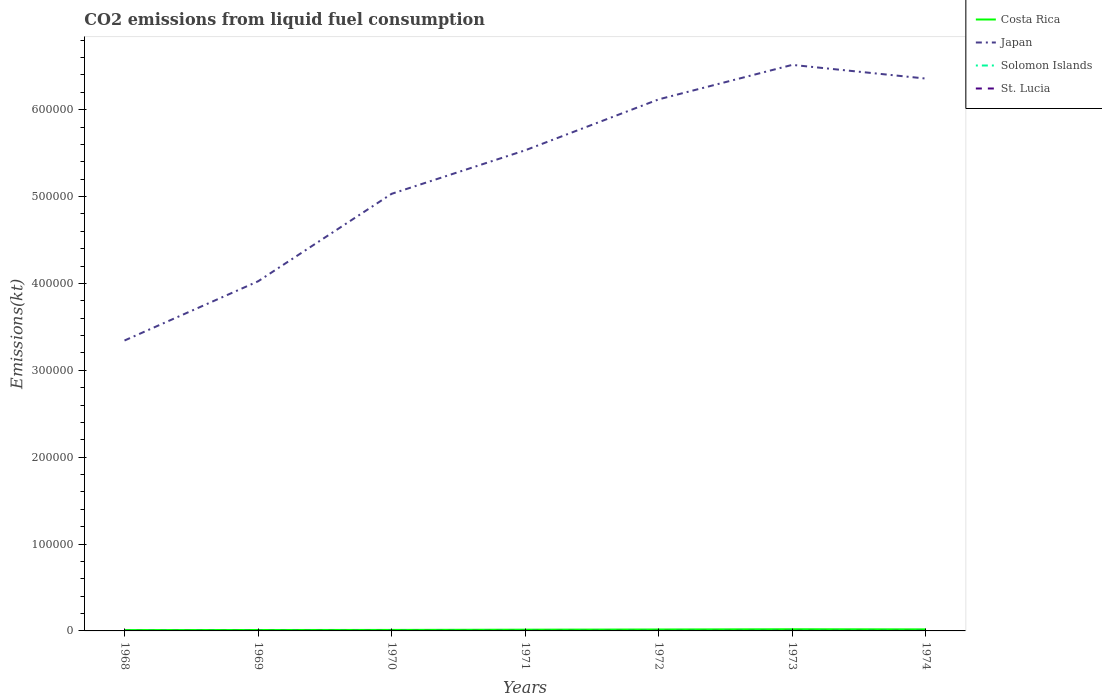How many different coloured lines are there?
Provide a succinct answer. 4. Does the line corresponding to Costa Rica intersect with the line corresponding to Solomon Islands?
Your answer should be compact. No. Across all years, what is the maximum amount of CO2 emitted in Costa Rica?
Offer a terse response. 971.75. In which year was the amount of CO2 emitted in St. Lucia maximum?
Ensure brevity in your answer.  1968. What is the total amount of CO2 emitted in Costa Rica in the graph?
Provide a succinct answer. -751.74. What is the difference between the highest and the second highest amount of CO2 emitted in St. Lucia?
Ensure brevity in your answer.  44. What is the difference between the highest and the lowest amount of CO2 emitted in St. Lucia?
Your answer should be compact. 4. How many lines are there?
Ensure brevity in your answer.  4. Are the values on the major ticks of Y-axis written in scientific E-notation?
Make the answer very short. No. Does the graph contain any zero values?
Give a very brief answer. No. Does the graph contain grids?
Ensure brevity in your answer.  No. Where does the legend appear in the graph?
Make the answer very short. Top right. How many legend labels are there?
Your answer should be compact. 4. How are the legend labels stacked?
Your answer should be very brief. Vertical. What is the title of the graph?
Make the answer very short. CO2 emissions from liquid fuel consumption. What is the label or title of the X-axis?
Offer a terse response. Years. What is the label or title of the Y-axis?
Provide a succinct answer. Emissions(kt). What is the Emissions(kt) of Costa Rica in 1968?
Your answer should be compact. 971.75. What is the Emissions(kt) in Japan in 1968?
Offer a terse response. 3.34e+05. What is the Emissions(kt) of Solomon Islands in 1968?
Your answer should be compact. 36.67. What is the Emissions(kt) in St. Lucia in 1968?
Ensure brevity in your answer.  36.67. What is the Emissions(kt) of Costa Rica in 1969?
Your answer should be very brief. 1067.1. What is the Emissions(kt) in Japan in 1969?
Your answer should be very brief. 4.02e+05. What is the Emissions(kt) in Solomon Islands in 1969?
Offer a terse response. 36.67. What is the Emissions(kt) in St. Lucia in 1969?
Offer a terse response. 62.34. What is the Emissions(kt) of Costa Rica in 1970?
Provide a short and direct response. 1158.77. What is the Emissions(kt) in Japan in 1970?
Provide a short and direct response. 5.03e+05. What is the Emissions(kt) in Solomon Islands in 1970?
Provide a succinct answer. 40.34. What is the Emissions(kt) of St. Lucia in 1970?
Offer a very short reply. 66.01. What is the Emissions(kt) of Costa Rica in 1971?
Provide a short and direct response. 1422.8. What is the Emissions(kt) in Japan in 1971?
Provide a short and direct response. 5.53e+05. What is the Emissions(kt) of Solomon Islands in 1971?
Keep it short and to the point. 47.67. What is the Emissions(kt) of St. Lucia in 1971?
Ensure brevity in your answer.  69.67. What is the Emissions(kt) in Costa Rica in 1972?
Your answer should be compact. 1631.82. What is the Emissions(kt) of Japan in 1972?
Offer a terse response. 6.12e+05. What is the Emissions(kt) in Solomon Islands in 1972?
Offer a very short reply. 55.01. What is the Emissions(kt) of St. Lucia in 1972?
Provide a short and direct response. 77.01. What is the Emissions(kt) in Costa Rica in 1973?
Make the answer very short. 1910.51. What is the Emissions(kt) of Japan in 1973?
Keep it short and to the point. 6.52e+05. What is the Emissions(kt) of Solomon Islands in 1973?
Provide a short and direct response. 66.01. What is the Emissions(kt) of St. Lucia in 1973?
Give a very brief answer. 80.67. What is the Emissions(kt) in Costa Rica in 1974?
Offer a terse response. 1760.16. What is the Emissions(kt) of Japan in 1974?
Your answer should be very brief. 6.36e+05. What is the Emissions(kt) of Solomon Islands in 1974?
Your answer should be very brief. 66.01. What is the Emissions(kt) of St. Lucia in 1974?
Make the answer very short. 73.34. Across all years, what is the maximum Emissions(kt) of Costa Rica?
Provide a short and direct response. 1910.51. Across all years, what is the maximum Emissions(kt) in Japan?
Offer a very short reply. 6.52e+05. Across all years, what is the maximum Emissions(kt) in Solomon Islands?
Provide a short and direct response. 66.01. Across all years, what is the maximum Emissions(kt) in St. Lucia?
Keep it short and to the point. 80.67. Across all years, what is the minimum Emissions(kt) of Costa Rica?
Make the answer very short. 971.75. Across all years, what is the minimum Emissions(kt) in Japan?
Your response must be concise. 3.34e+05. Across all years, what is the minimum Emissions(kt) in Solomon Islands?
Your answer should be very brief. 36.67. Across all years, what is the minimum Emissions(kt) of St. Lucia?
Your answer should be very brief. 36.67. What is the total Emissions(kt) in Costa Rica in the graph?
Keep it short and to the point. 9922.9. What is the total Emissions(kt) in Japan in the graph?
Provide a short and direct response. 3.69e+06. What is the total Emissions(kt) in Solomon Islands in the graph?
Offer a terse response. 348.37. What is the total Emissions(kt) of St. Lucia in the graph?
Your answer should be compact. 465.71. What is the difference between the Emissions(kt) in Costa Rica in 1968 and that in 1969?
Your answer should be compact. -95.34. What is the difference between the Emissions(kt) of Japan in 1968 and that in 1969?
Make the answer very short. -6.81e+04. What is the difference between the Emissions(kt) in Solomon Islands in 1968 and that in 1969?
Provide a succinct answer. 0. What is the difference between the Emissions(kt) of St. Lucia in 1968 and that in 1969?
Provide a short and direct response. -25.67. What is the difference between the Emissions(kt) of Costa Rica in 1968 and that in 1970?
Give a very brief answer. -187.02. What is the difference between the Emissions(kt) in Japan in 1968 and that in 1970?
Provide a short and direct response. -1.69e+05. What is the difference between the Emissions(kt) in Solomon Islands in 1968 and that in 1970?
Ensure brevity in your answer.  -3.67. What is the difference between the Emissions(kt) of St. Lucia in 1968 and that in 1970?
Offer a very short reply. -29.34. What is the difference between the Emissions(kt) in Costa Rica in 1968 and that in 1971?
Offer a terse response. -451.04. What is the difference between the Emissions(kt) of Japan in 1968 and that in 1971?
Give a very brief answer. -2.19e+05. What is the difference between the Emissions(kt) in Solomon Islands in 1968 and that in 1971?
Your response must be concise. -11. What is the difference between the Emissions(kt) in St. Lucia in 1968 and that in 1971?
Provide a short and direct response. -33. What is the difference between the Emissions(kt) in Costa Rica in 1968 and that in 1972?
Give a very brief answer. -660.06. What is the difference between the Emissions(kt) of Japan in 1968 and that in 1972?
Provide a succinct answer. -2.78e+05. What is the difference between the Emissions(kt) in Solomon Islands in 1968 and that in 1972?
Keep it short and to the point. -18.34. What is the difference between the Emissions(kt) of St. Lucia in 1968 and that in 1972?
Your answer should be compact. -40.34. What is the difference between the Emissions(kt) in Costa Rica in 1968 and that in 1973?
Offer a terse response. -938.75. What is the difference between the Emissions(kt) in Japan in 1968 and that in 1973?
Your answer should be compact. -3.17e+05. What is the difference between the Emissions(kt) in Solomon Islands in 1968 and that in 1973?
Provide a short and direct response. -29.34. What is the difference between the Emissions(kt) of St. Lucia in 1968 and that in 1973?
Provide a short and direct response. -44. What is the difference between the Emissions(kt) of Costa Rica in 1968 and that in 1974?
Your answer should be very brief. -788.4. What is the difference between the Emissions(kt) in Japan in 1968 and that in 1974?
Your response must be concise. -3.02e+05. What is the difference between the Emissions(kt) of Solomon Islands in 1968 and that in 1974?
Your answer should be very brief. -29.34. What is the difference between the Emissions(kt) in St. Lucia in 1968 and that in 1974?
Offer a terse response. -36.67. What is the difference between the Emissions(kt) in Costa Rica in 1969 and that in 1970?
Provide a succinct answer. -91.67. What is the difference between the Emissions(kt) of Japan in 1969 and that in 1970?
Keep it short and to the point. -1.01e+05. What is the difference between the Emissions(kt) of Solomon Islands in 1969 and that in 1970?
Offer a terse response. -3.67. What is the difference between the Emissions(kt) in St. Lucia in 1969 and that in 1970?
Your answer should be very brief. -3.67. What is the difference between the Emissions(kt) of Costa Rica in 1969 and that in 1971?
Give a very brief answer. -355.7. What is the difference between the Emissions(kt) in Japan in 1969 and that in 1971?
Offer a terse response. -1.51e+05. What is the difference between the Emissions(kt) in Solomon Islands in 1969 and that in 1971?
Ensure brevity in your answer.  -11. What is the difference between the Emissions(kt) of St. Lucia in 1969 and that in 1971?
Keep it short and to the point. -7.33. What is the difference between the Emissions(kt) of Costa Rica in 1969 and that in 1972?
Keep it short and to the point. -564.72. What is the difference between the Emissions(kt) of Japan in 1969 and that in 1972?
Your answer should be very brief. -2.09e+05. What is the difference between the Emissions(kt) in Solomon Islands in 1969 and that in 1972?
Provide a short and direct response. -18.34. What is the difference between the Emissions(kt) in St. Lucia in 1969 and that in 1972?
Keep it short and to the point. -14.67. What is the difference between the Emissions(kt) of Costa Rica in 1969 and that in 1973?
Keep it short and to the point. -843.41. What is the difference between the Emissions(kt) of Japan in 1969 and that in 1973?
Provide a short and direct response. -2.49e+05. What is the difference between the Emissions(kt) of Solomon Islands in 1969 and that in 1973?
Provide a short and direct response. -29.34. What is the difference between the Emissions(kt) in St. Lucia in 1969 and that in 1973?
Provide a succinct answer. -18.34. What is the difference between the Emissions(kt) of Costa Rica in 1969 and that in 1974?
Give a very brief answer. -693.06. What is the difference between the Emissions(kt) of Japan in 1969 and that in 1974?
Provide a succinct answer. -2.33e+05. What is the difference between the Emissions(kt) of Solomon Islands in 1969 and that in 1974?
Provide a succinct answer. -29.34. What is the difference between the Emissions(kt) of St. Lucia in 1969 and that in 1974?
Offer a very short reply. -11. What is the difference between the Emissions(kt) of Costa Rica in 1970 and that in 1971?
Ensure brevity in your answer.  -264.02. What is the difference between the Emissions(kt) in Japan in 1970 and that in 1971?
Make the answer very short. -5.01e+04. What is the difference between the Emissions(kt) in Solomon Islands in 1970 and that in 1971?
Offer a very short reply. -7.33. What is the difference between the Emissions(kt) in St. Lucia in 1970 and that in 1971?
Your answer should be compact. -3.67. What is the difference between the Emissions(kt) of Costa Rica in 1970 and that in 1972?
Your response must be concise. -473.04. What is the difference between the Emissions(kt) in Japan in 1970 and that in 1972?
Provide a short and direct response. -1.09e+05. What is the difference between the Emissions(kt) in Solomon Islands in 1970 and that in 1972?
Your answer should be very brief. -14.67. What is the difference between the Emissions(kt) of St. Lucia in 1970 and that in 1972?
Your response must be concise. -11. What is the difference between the Emissions(kt) of Costa Rica in 1970 and that in 1973?
Your answer should be very brief. -751.74. What is the difference between the Emissions(kt) in Japan in 1970 and that in 1973?
Ensure brevity in your answer.  -1.48e+05. What is the difference between the Emissions(kt) of Solomon Islands in 1970 and that in 1973?
Give a very brief answer. -25.67. What is the difference between the Emissions(kt) in St. Lucia in 1970 and that in 1973?
Keep it short and to the point. -14.67. What is the difference between the Emissions(kt) of Costa Rica in 1970 and that in 1974?
Offer a very short reply. -601.39. What is the difference between the Emissions(kt) in Japan in 1970 and that in 1974?
Provide a short and direct response. -1.33e+05. What is the difference between the Emissions(kt) in Solomon Islands in 1970 and that in 1974?
Give a very brief answer. -25.67. What is the difference between the Emissions(kt) in St. Lucia in 1970 and that in 1974?
Keep it short and to the point. -7.33. What is the difference between the Emissions(kt) in Costa Rica in 1971 and that in 1972?
Your answer should be very brief. -209.02. What is the difference between the Emissions(kt) of Japan in 1971 and that in 1972?
Keep it short and to the point. -5.87e+04. What is the difference between the Emissions(kt) of Solomon Islands in 1971 and that in 1972?
Provide a succinct answer. -7.33. What is the difference between the Emissions(kt) in St. Lucia in 1971 and that in 1972?
Keep it short and to the point. -7.33. What is the difference between the Emissions(kt) of Costa Rica in 1971 and that in 1973?
Offer a very short reply. -487.71. What is the difference between the Emissions(kt) in Japan in 1971 and that in 1973?
Your answer should be compact. -9.83e+04. What is the difference between the Emissions(kt) in Solomon Islands in 1971 and that in 1973?
Ensure brevity in your answer.  -18.34. What is the difference between the Emissions(kt) in St. Lucia in 1971 and that in 1973?
Your response must be concise. -11. What is the difference between the Emissions(kt) of Costa Rica in 1971 and that in 1974?
Give a very brief answer. -337.36. What is the difference between the Emissions(kt) of Japan in 1971 and that in 1974?
Give a very brief answer. -8.26e+04. What is the difference between the Emissions(kt) in Solomon Islands in 1971 and that in 1974?
Ensure brevity in your answer.  -18.34. What is the difference between the Emissions(kt) in St. Lucia in 1971 and that in 1974?
Ensure brevity in your answer.  -3.67. What is the difference between the Emissions(kt) of Costa Rica in 1972 and that in 1973?
Offer a terse response. -278.69. What is the difference between the Emissions(kt) in Japan in 1972 and that in 1973?
Your response must be concise. -3.97e+04. What is the difference between the Emissions(kt) of Solomon Islands in 1972 and that in 1973?
Ensure brevity in your answer.  -11. What is the difference between the Emissions(kt) of St. Lucia in 1972 and that in 1973?
Make the answer very short. -3.67. What is the difference between the Emissions(kt) of Costa Rica in 1972 and that in 1974?
Provide a succinct answer. -128.34. What is the difference between the Emissions(kt) in Japan in 1972 and that in 1974?
Your answer should be compact. -2.39e+04. What is the difference between the Emissions(kt) of Solomon Islands in 1972 and that in 1974?
Give a very brief answer. -11. What is the difference between the Emissions(kt) of St. Lucia in 1972 and that in 1974?
Give a very brief answer. 3.67. What is the difference between the Emissions(kt) of Costa Rica in 1973 and that in 1974?
Make the answer very short. 150.35. What is the difference between the Emissions(kt) of Japan in 1973 and that in 1974?
Offer a very short reply. 1.58e+04. What is the difference between the Emissions(kt) of Solomon Islands in 1973 and that in 1974?
Your answer should be compact. 0. What is the difference between the Emissions(kt) in St. Lucia in 1973 and that in 1974?
Provide a succinct answer. 7.33. What is the difference between the Emissions(kt) in Costa Rica in 1968 and the Emissions(kt) in Japan in 1969?
Provide a succinct answer. -4.01e+05. What is the difference between the Emissions(kt) in Costa Rica in 1968 and the Emissions(kt) in Solomon Islands in 1969?
Your answer should be compact. 935.09. What is the difference between the Emissions(kt) in Costa Rica in 1968 and the Emissions(kt) in St. Lucia in 1969?
Your answer should be compact. 909.42. What is the difference between the Emissions(kt) in Japan in 1968 and the Emissions(kt) in Solomon Islands in 1969?
Your response must be concise. 3.34e+05. What is the difference between the Emissions(kt) in Japan in 1968 and the Emissions(kt) in St. Lucia in 1969?
Provide a succinct answer. 3.34e+05. What is the difference between the Emissions(kt) in Solomon Islands in 1968 and the Emissions(kt) in St. Lucia in 1969?
Ensure brevity in your answer.  -25.67. What is the difference between the Emissions(kt) of Costa Rica in 1968 and the Emissions(kt) of Japan in 1970?
Provide a succinct answer. -5.02e+05. What is the difference between the Emissions(kt) in Costa Rica in 1968 and the Emissions(kt) in Solomon Islands in 1970?
Your response must be concise. 931.42. What is the difference between the Emissions(kt) in Costa Rica in 1968 and the Emissions(kt) in St. Lucia in 1970?
Make the answer very short. 905.75. What is the difference between the Emissions(kt) in Japan in 1968 and the Emissions(kt) in Solomon Islands in 1970?
Your response must be concise. 3.34e+05. What is the difference between the Emissions(kt) in Japan in 1968 and the Emissions(kt) in St. Lucia in 1970?
Your answer should be very brief. 3.34e+05. What is the difference between the Emissions(kt) in Solomon Islands in 1968 and the Emissions(kt) in St. Lucia in 1970?
Your answer should be compact. -29.34. What is the difference between the Emissions(kt) of Costa Rica in 1968 and the Emissions(kt) of Japan in 1971?
Make the answer very short. -5.52e+05. What is the difference between the Emissions(kt) in Costa Rica in 1968 and the Emissions(kt) in Solomon Islands in 1971?
Provide a short and direct response. 924.08. What is the difference between the Emissions(kt) in Costa Rica in 1968 and the Emissions(kt) in St. Lucia in 1971?
Your answer should be compact. 902.08. What is the difference between the Emissions(kt) in Japan in 1968 and the Emissions(kt) in Solomon Islands in 1971?
Keep it short and to the point. 3.34e+05. What is the difference between the Emissions(kt) of Japan in 1968 and the Emissions(kt) of St. Lucia in 1971?
Your answer should be very brief. 3.34e+05. What is the difference between the Emissions(kt) of Solomon Islands in 1968 and the Emissions(kt) of St. Lucia in 1971?
Ensure brevity in your answer.  -33. What is the difference between the Emissions(kt) of Costa Rica in 1968 and the Emissions(kt) of Japan in 1972?
Provide a succinct answer. -6.11e+05. What is the difference between the Emissions(kt) in Costa Rica in 1968 and the Emissions(kt) in Solomon Islands in 1972?
Make the answer very short. 916.75. What is the difference between the Emissions(kt) in Costa Rica in 1968 and the Emissions(kt) in St. Lucia in 1972?
Provide a short and direct response. 894.75. What is the difference between the Emissions(kt) in Japan in 1968 and the Emissions(kt) in Solomon Islands in 1972?
Ensure brevity in your answer.  3.34e+05. What is the difference between the Emissions(kt) in Japan in 1968 and the Emissions(kt) in St. Lucia in 1972?
Your answer should be compact. 3.34e+05. What is the difference between the Emissions(kt) of Solomon Islands in 1968 and the Emissions(kt) of St. Lucia in 1972?
Give a very brief answer. -40.34. What is the difference between the Emissions(kt) in Costa Rica in 1968 and the Emissions(kt) in Japan in 1973?
Ensure brevity in your answer.  -6.51e+05. What is the difference between the Emissions(kt) of Costa Rica in 1968 and the Emissions(kt) of Solomon Islands in 1973?
Offer a very short reply. 905.75. What is the difference between the Emissions(kt) in Costa Rica in 1968 and the Emissions(kt) in St. Lucia in 1973?
Make the answer very short. 891.08. What is the difference between the Emissions(kt) of Japan in 1968 and the Emissions(kt) of Solomon Islands in 1973?
Make the answer very short. 3.34e+05. What is the difference between the Emissions(kt) of Japan in 1968 and the Emissions(kt) of St. Lucia in 1973?
Ensure brevity in your answer.  3.34e+05. What is the difference between the Emissions(kt) of Solomon Islands in 1968 and the Emissions(kt) of St. Lucia in 1973?
Offer a terse response. -44. What is the difference between the Emissions(kt) in Costa Rica in 1968 and the Emissions(kt) in Japan in 1974?
Your answer should be compact. -6.35e+05. What is the difference between the Emissions(kt) of Costa Rica in 1968 and the Emissions(kt) of Solomon Islands in 1974?
Offer a very short reply. 905.75. What is the difference between the Emissions(kt) of Costa Rica in 1968 and the Emissions(kt) of St. Lucia in 1974?
Keep it short and to the point. 898.41. What is the difference between the Emissions(kt) in Japan in 1968 and the Emissions(kt) in Solomon Islands in 1974?
Provide a succinct answer. 3.34e+05. What is the difference between the Emissions(kt) in Japan in 1968 and the Emissions(kt) in St. Lucia in 1974?
Ensure brevity in your answer.  3.34e+05. What is the difference between the Emissions(kt) in Solomon Islands in 1968 and the Emissions(kt) in St. Lucia in 1974?
Provide a succinct answer. -36.67. What is the difference between the Emissions(kt) in Costa Rica in 1969 and the Emissions(kt) in Japan in 1970?
Keep it short and to the point. -5.02e+05. What is the difference between the Emissions(kt) in Costa Rica in 1969 and the Emissions(kt) in Solomon Islands in 1970?
Offer a terse response. 1026.76. What is the difference between the Emissions(kt) in Costa Rica in 1969 and the Emissions(kt) in St. Lucia in 1970?
Make the answer very short. 1001.09. What is the difference between the Emissions(kt) in Japan in 1969 and the Emissions(kt) in Solomon Islands in 1970?
Keep it short and to the point. 4.02e+05. What is the difference between the Emissions(kt) of Japan in 1969 and the Emissions(kt) of St. Lucia in 1970?
Your response must be concise. 4.02e+05. What is the difference between the Emissions(kt) in Solomon Islands in 1969 and the Emissions(kt) in St. Lucia in 1970?
Offer a terse response. -29.34. What is the difference between the Emissions(kt) in Costa Rica in 1969 and the Emissions(kt) in Japan in 1971?
Provide a short and direct response. -5.52e+05. What is the difference between the Emissions(kt) in Costa Rica in 1969 and the Emissions(kt) in Solomon Islands in 1971?
Keep it short and to the point. 1019.43. What is the difference between the Emissions(kt) in Costa Rica in 1969 and the Emissions(kt) in St. Lucia in 1971?
Make the answer very short. 997.42. What is the difference between the Emissions(kt) in Japan in 1969 and the Emissions(kt) in Solomon Islands in 1971?
Make the answer very short. 4.02e+05. What is the difference between the Emissions(kt) of Japan in 1969 and the Emissions(kt) of St. Lucia in 1971?
Provide a succinct answer. 4.02e+05. What is the difference between the Emissions(kt) of Solomon Islands in 1969 and the Emissions(kt) of St. Lucia in 1971?
Your answer should be very brief. -33. What is the difference between the Emissions(kt) of Costa Rica in 1969 and the Emissions(kt) of Japan in 1972?
Keep it short and to the point. -6.11e+05. What is the difference between the Emissions(kt) in Costa Rica in 1969 and the Emissions(kt) in Solomon Islands in 1972?
Offer a very short reply. 1012.09. What is the difference between the Emissions(kt) of Costa Rica in 1969 and the Emissions(kt) of St. Lucia in 1972?
Make the answer very short. 990.09. What is the difference between the Emissions(kt) in Japan in 1969 and the Emissions(kt) in Solomon Islands in 1972?
Offer a very short reply. 4.02e+05. What is the difference between the Emissions(kt) of Japan in 1969 and the Emissions(kt) of St. Lucia in 1972?
Your answer should be compact. 4.02e+05. What is the difference between the Emissions(kt) of Solomon Islands in 1969 and the Emissions(kt) of St. Lucia in 1972?
Ensure brevity in your answer.  -40.34. What is the difference between the Emissions(kt) in Costa Rica in 1969 and the Emissions(kt) in Japan in 1973?
Provide a succinct answer. -6.50e+05. What is the difference between the Emissions(kt) in Costa Rica in 1969 and the Emissions(kt) in Solomon Islands in 1973?
Keep it short and to the point. 1001.09. What is the difference between the Emissions(kt) in Costa Rica in 1969 and the Emissions(kt) in St. Lucia in 1973?
Offer a very short reply. 986.42. What is the difference between the Emissions(kt) of Japan in 1969 and the Emissions(kt) of Solomon Islands in 1973?
Provide a short and direct response. 4.02e+05. What is the difference between the Emissions(kt) in Japan in 1969 and the Emissions(kt) in St. Lucia in 1973?
Your response must be concise. 4.02e+05. What is the difference between the Emissions(kt) in Solomon Islands in 1969 and the Emissions(kt) in St. Lucia in 1973?
Provide a short and direct response. -44. What is the difference between the Emissions(kt) of Costa Rica in 1969 and the Emissions(kt) of Japan in 1974?
Your answer should be compact. -6.35e+05. What is the difference between the Emissions(kt) of Costa Rica in 1969 and the Emissions(kt) of Solomon Islands in 1974?
Your answer should be compact. 1001.09. What is the difference between the Emissions(kt) in Costa Rica in 1969 and the Emissions(kt) in St. Lucia in 1974?
Provide a succinct answer. 993.76. What is the difference between the Emissions(kt) in Japan in 1969 and the Emissions(kt) in Solomon Islands in 1974?
Offer a very short reply. 4.02e+05. What is the difference between the Emissions(kt) in Japan in 1969 and the Emissions(kt) in St. Lucia in 1974?
Your answer should be very brief. 4.02e+05. What is the difference between the Emissions(kt) in Solomon Islands in 1969 and the Emissions(kt) in St. Lucia in 1974?
Provide a succinct answer. -36.67. What is the difference between the Emissions(kt) of Costa Rica in 1970 and the Emissions(kt) of Japan in 1971?
Keep it short and to the point. -5.52e+05. What is the difference between the Emissions(kt) in Costa Rica in 1970 and the Emissions(kt) in Solomon Islands in 1971?
Keep it short and to the point. 1111.1. What is the difference between the Emissions(kt) in Costa Rica in 1970 and the Emissions(kt) in St. Lucia in 1971?
Provide a succinct answer. 1089.1. What is the difference between the Emissions(kt) in Japan in 1970 and the Emissions(kt) in Solomon Islands in 1971?
Give a very brief answer. 5.03e+05. What is the difference between the Emissions(kt) of Japan in 1970 and the Emissions(kt) of St. Lucia in 1971?
Ensure brevity in your answer.  5.03e+05. What is the difference between the Emissions(kt) in Solomon Islands in 1970 and the Emissions(kt) in St. Lucia in 1971?
Offer a very short reply. -29.34. What is the difference between the Emissions(kt) in Costa Rica in 1970 and the Emissions(kt) in Japan in 1972?
Offer a very short reply. -6.11e+05. What is the difference between the Emissions(kt) in Costa Rica in 1970 and the Emissions(kt) in Solomon Islands in 1972?
Your response must be concise. 1103.77. What is the difference between the Emissions(kt) in Costa Rica in 1970 and the Emissions(kt) in St. Lucia in 1972?
Offer a terse response. 1081.77. What is the difference between the Emissions(kt) in Japan in 1970 and the Emissions(kt) in Solomon Islands in 1972?
Offer a terse response. 5.03e+05. What is the difference between the Emissions(kt) in Japan in 1970 and the Emissions(kt) in St. Lucia in 1972?
Provide a succinct answer. 5.03e+05. What is the difference between the Emissions(kt) in Solomon Islands in 1970 and the Emissions(kt) in St. Lucia in 1972?
Your response must be concise. -36.67. What is the difference between the Emissions(kt) in Costa Rica in 1970 and the Emissions(kt) in Japan in 1973?
Give a very brief answer. -6.50e+05. What is the difference between the Emissions(kt) in Costa Rica in 1970 and the Emissions(kt) in Solomon Islands in 1973?
Give a very brief answer. 1092.77. What is the difference between the Emissions(kt) in Costa Rica in 1970 and the Emissions(kt) in St. Lucia in 1973?
Your response must be concise. 1078.1. What is the difference between the Emissions(kt) of Japan in 1970 and the Emissions(kt) of Solomon Islands in 1973?
Give a very brief answer. 5.03e+05. What is the difference between the Emissions(kt) in Japan in 1970 and the Emissions(kt) in St. Lucia in 1973?
Provide a short and direct response. 5.03e+05. What is the difference between the Emissions(kt) in Solomon Islands in 1970 and the Emissions(kt) in St. Lucia in 1973?
Keep it short and to the point. -40.34. What is the difference between the Emissions(kt) in Costa Rica in 1970 and the Emissions(kt) in Japan in 1974?
Offer a terse response. -6.35e+05. What is the difference between the Emissions(kt) of Costa Rica in 1970 and the Emissions(kt) of Solomon Islands in 1974?
Provide a short and direct response. 1092.77. What is the difference between the Emissions(kt) of Costa Rica in 1970 and the Emissions(kt) of St. Lucia in 1974?
Your answer should be very brief. 1085.43. What is the difference between the Emissions(kt) in Japan in 1970 and the Emissions(kt) in Solomon Islands in 1974?
Keep it short and to the point. 5.03e+05. What is the difference between the Emissions(kt) of Japan in 1970 and the Emissions(kt) of St. Lucia in 1974?
Offer a very short reply. 5.03e+05. What is the difference between the Emissions(kt) of Solomon Islands in 1970 and the Emissions(kt) of St. Lucia in 1974?
Give a very brief answer. -33. What is the difference between the Emissions(kt) of Costa Rica in 1971 and the Emissions(kt) of Japan in 1972?
Offer a terse response. -6.10e+05. What is the difference between the Emissions(kt) in Costa Rica in 1971 and the Emissions(kt) in Solomon Islands in 1972?
Your response must be concise. 1367.79. What is the difference between the Emissions(kt) in Costa Rica in 1971 and the Emissions(kt) in St. Lucia in 1972?
Your response must be concise. 1345.79. What is the difference between the Emissions(kt) of Japan in 1971 and the Emissions(kt) of Solomon Islands in 1972?
Your response must be concise. 5.53e+05. What is the difference between the Emissions(kt) in Japan in 1971 and the Emissions(kt) in St. Lucia in 1972?
Your response must be concise. 5.53e+05. What is the difference between the Emissions(kt) of Solomon Islands in 1971 and the Emissions(kt) of St. Lucia in 1972?
Provide a succinct answer. -29.34. What is the difference between the Emissions(kt) in Costa Rica in 1971 and the Emissions(kt) in Japan in 1973?
Provide a succinct answer. -6.50e+05. What is the difference between the Emissions(kt) in Costa Rica in 1971 and the Emissions(kt) in Solomon Islands in 1973?
Offer a terse response. 1356.79. What is the difference between the Emissions(kt) in Costa Rica in 1971 and the Emissions(kt) in St. Lucia in 1973?
Your answer should be very brief. 1342.12. What is the difference between the Emissions(kt) of Japan in 1971 and the Emissions(kt) of Solomon Islands in 1973?
Provide a succinct answer. 5.53e+05. What is the difference between the Emissions(kt) in Japan in 1971 and the Emissions(kt) in St. Lucia in 1973?
Offer a very short reply. 5.53e+05. What is the difference between the Emissions(kt) of Solomon Islands in 1971 and the Emissions(kt) of St. Lucia in 1973?
Keep it short and to the point. -33. What is the difference between the Emissions(kt) of Costa Rica in 1971 and the Emissions(kt) of Japan in 1974?
Offer a terse response. -6.34e+05. What is the difference between the Emissions(kt) in Costa Rica in 1971 and the Emissions(kt) in Solomon Islands in 1974?
Offer a very short reply. 1356.79. What is the difference between the Emissions(kt) of Costa Rica in 1971 and the Emissions(kt) of St. Lucia in 1974?
Give a very brief answer. 1349.46. What is the difference between the Emissions(kt) of Japan in 1971 and the Emissions(kt) of Solomon Islands in 1974?
Offer a terse response. 5.53e+05. What is the difference between the Emissions(kt) of Japan in 1971 and the Emissions(kt) of St. Lucia in 1974?
Your answer should be very brief. 5.53e+05. What is the difference between the Emissions(kt) of Solomon Islands in 1971 and the Emissions(kt) of St. Lucia in 1974?
Make the answer very short. -25.67. What is the difference between the Emissions(kt) in Costa Rica in 1972 and the Emissions(kt) in Japan in 1973?
Give a very brief answer. -6.50e+05. What is the difference between the Emissions(kt) in Costa Rica in 1972 and the Emissions(kt) in Solomon Islands in 1973?
Ensure brevity in your answer.  1565.81. What is the difference between the Emissions(kt) in Costa Rica in 1972 and the Emissions(kt) in St. Lucia in 1973?
Make the answer very short. 1551.14. What is the difference between the Emissions(kt) in Japan in 1972 and the Emissions(kt) in Solomon Islands in 1973?
Offer a terse response. 6.12e+05. What is the difference between the Emissions(kt) of Japan in 1972 and the Emissions(kt) of St. Lucia in 1973?
Provide a succinct answer. 6.12e+05. What is the difference between the Emissions(kt) of Solomon Islands in 1972 and the Emissions(kt) of St. Lucia in 1973?
Provide a short and direct response. -25.67. What is the difference between the Emissions(kt) of Costa Rica in 1972 and the Emissions(kt) of Japan in 1974?
Your answer should be very brief. -6.34e+05. What is the difference between the Emissions(kt) in Costa Rica in 1972 and the Emissions(kt) in Solomon Islands in 1974?
Keep it short and to the point. 1565.81. What is the difference between the Emissions(kt) in Costa Rica in 1972 and the Emissions(kt) in St. Lucia in 1974?
Your response must be concise. 1558.47. What is the difference between the Emissions(kt) in Japan in 1972 and the Emissions(kt) in Solomon Islands in 1974?
Make the answer very short. 6.12e+05. What is the difference between the Emissions(kt) in Japan in 1972 and the Emissions(kt) in St. Lucia in 1974?
Ensure brevity in your answer.  6.12e+05. What is the difference between the Emissions(kt) of Solomon Islands in 1972 and the Emissions(kt) of St. Lucia in 1974?
Provide a short and direct response. -18.34. What is the difference between the Emissions(kt) in Costa Rica in 1973 and the Emissions(kt) in Japan in 1974?
Your response must be concise. -6.34e+05. What is the difference between the Emissions(kt) of Costa Rica in 1973 and the Emissions(kt) of Solomon Islands in 1974?
Provide a short and direct response. 1844.5. What is the difference between the Emissions(kt) of Costa Rica in 1973 and the Emissions(kt) of St. Lucia in 1974?
Offer a very short reply. 1837.17. What is the difference between the Emissions(kt) of Japan in 1973 and the Emissions(kt) of Solomon Islands in 1974?
Offer a very short reply. 6.51e+05. What is the difference between the Emissions(kt) in Japan in 1973 and the Emissions(kt) in St. Lucia in 1974?
Offer a terse response. 6.51e+05. What is the difference between the Emissions(kt) of Solomon Islands in 1973 and the Emissions(kt) of St. Lucia in 1974?
Your answer should be compact. -7.33. What is the average Emissions(kt) in Costa Rica per year?
Your response must be concise. 1417.56. What is the average Emissions(kt) of Japan per year?
Offer a very short reply. 5.27e+05. What is the average Emissions(kt) in Solomon Islands per year?
Your answer should be very brief. 49.77. What is the average Emissions(kt) of St. Lucia per year?
Your response must be concise. 66.53. In the year 1968, what is the difference between the Emissions(kt) in Costa Rica and Emissions(kt) in Japan?
Offer a very short reply. -3.33e+05. In the year 1968, what is the difference between the Emissions(kt) in Costa Rica and Emissions(kt) in Solomon Islands?
Make the answer very short. 935.09. In the year 1968, what is the difference between the Emissions(kt) of Costa Rica and Emissions(kt) of St. Lucia?
Offer a terse response. 935.09. In the year 1968, what is the difference between the Emissions(kt) of Japan and Emissions(kt) of Solomon Islands?
Offer a terse response. 3.34e+05. In the year 1968, what is the difference between the Emissions(kt) in Japan and Emissions(kt) in St. Lucia?
Give a very brief answer. 3.34e+05. In the year 1968, what is the difference between the Emissions(kt) in Solomon Islands and Emissions(kt) in St. Lucia?
Ensure brevity in your answer.  0. In the year 1969, what is the difference between the Emissions(kt) of Costa Rica and Emissions(kt) of Japan?
Offer a very short reply. -4.01e+05. In the year 1969, what is the difference between the Emissions(kt) in Costa Rica and Emissions(kt) in Solomon Islands?
Ensure brevity in your answer.  1030.43. In the year 1969, what is the difference between the Emissions(kt) of Costa Rica and Emissions(kt) of St. Lucia?
Offer a terse response. 1004.76. In the year 1969, what is the difference between the Emissions(kt) of Japan and Emissions(kt) of Solomon Islands?
Offer a terse response. 4.02e+05. In the year 1969, what is the difference between the Emissions(kt) of Japan and Emissions(kt) of St. Lucia?
Give a very brief answer. 4.02e+05. In the year 1969, what is the difference between the Emissions(kt) in Solomon Islands and Emissions(kt) in St. Lucia?
Ensure brevity in your answer.  -25.67. In the year 1970, what is the difference between the Emissions(kt) of Costa Rica and Emissions(kt) of Japan?
Make the answer very short. -5.02e+05. In the year 1970, what is the difference between the Emissions(kt) in Costa Rica and Emissions(kt) in Solomon Islands?
Provide a succinct answer. 1118.43. In the year 1970, what is the difference between the Emissions(kt) of Costa Rica and Emissions(kt) of St. Lucia?
Offer a very short reply. 1092.77. In the year 1970, what is the difference between the Emissions(kt) of Japan and Emissions(kt) of Solomon Islands?
Give a very brief answer. 5.03e+05. In the year 1970, what is the difference between the Emissions(kt) in Japan and Emissions(kt) in St. Lucia?
Your answer should be very brief. 5.03e+05. In the year 1970, what is the difference between the Emissions(kt) in Solomon Islands and Emissions(kt) in St. Lucia?
Give a very brief answer. -25.67. In the year 1971, what is the difference between the Emissions(kt) in Costa Rica and Emissions(kt) in Japan?
Your answer should be compact. -5.52e+05. In the year 1971, what is the difference between the Emissions(kt) of Costa Rica and Emissions(kt) of Solomon Islands?
Keep it short and to the point. 1375.12. In the year 1971, what is the difference between the Emissions(kt) in Costa Rica and Emissions(kt) in St. Lucia?
Make the answer very short. 1353.12. In the year 1971, what is the difference between the Emissions(kt) of Japan and Emissions(kt) of Solomon Islands?
Ensure brevity in your answer.  5.53e+05. In the year 1971, what is the difference between the Emissions(kt) in Japan and Emissions(kt) in St. Lucia?
Your answer should be compact. 5.53e+05. In the year 1971, what is the difference between the Emissions(kt) in Solomon Islands and Emissions(kt) in St. Lucia?
Your response must be concise. -22. In the year 1972, what is the difference between the Emissions(kt) of Costa Rica and Emissions(kt) of Japan?
Give a very brief answer. -6.10e+05. In the year 1972, what is the difference between the Emissions(kt) of Costa Rica and Emissions(kt) of Solomon Islands?
Your response must be concise. 1576.81. In the year 1972, what is the difference between the Emissions(kt) in Costa Rica and Emissions(kt) in St. Lucia?
Provide a succinct answer. 1554.81. In the year 1972, what is the difference between the Emissions(kt) in Japan and Emissions(kt) in Solomon Islands?
Ensure brevity in your answer.  6.12e+05. In the year 1972, what is the difference between the Emissions(kt) in Japan and Emissions(kt) in St. Lucia?
Make the answer very short. 6.12e+05. In the year 1972, what is the difference between the Emissions(kt) of Solomon Islands and Emissions(kt) of St. Lucia?
Your answer should be compact. -22. In the year 1973, what is the difference between the Emissions(kt) of Costa Rica and Emissions(kt) of Japan?
Provide a succinct answer. -6.50e+05. In the year 1973, what is the difference between the Emissions(kt) of Costa Rica and Emissions(kt) of Solomon Islands?
Your response must be concise. 1844.5. In the year 1973, what is the difference between the Emissions(kt) in Costa Rica and Emissions(kt) in St. Lucia?
Provide a succinct answer. 1829.83. In the year 1973, what is the difference between the Emissions(kt) of Japan and Emissions(kt) of Solomon Islands?
Keep it short and to the point. 6.51e+05. In the year 1973, what is the difference between the Emissions(kt) of Japan and Emissions(kt) of St. Lucia?
Keep it short and to the point. 6.51e+05. In the year 1973, what is the difference between the Emissions(kt) of Solomon Islands and Emissions(kt) of St. Lucia?
Your response must be concise. -14.67. In the year 1974, what is the difference between the Emissions(kt) of Costa Rica and Emissions(kt) of Japan?
Your answer should be very brief. -6.34e+05. In the year 1974, what is the difference between the Emissions(kt) in Costa Rica and Emissions(kt) in Solomon Islands?
Your answer should be very brief. 1694.15. In the year 1974, what is the difference between the Emissions(kt) in Costa Rica and Emissions(kt) in St. Lucia?
Your answer should be compact. 1686.82. In the year 1974, what is the difference between the Emissions(kt) of Japan and Emissions(kt) of Solomon Islands?
Your response must be concise. 6.36e+05. In the year 1974, what is the difference between the Emissions(kt) in Japan and Emissions(kt) in St. Lucia?
Keep it short and to the point. 6.36e+05. In the year 1974, what is the difference between the Emissions(kt) in Solomon Islands and Emissions(kt) in St. Lucia?
Give a very brief answer. -7.33. What is the ratio of the Emissions(kt) in Costa Rica in 1968 to that in 1969?
Your answer should be very brief. 0.91. What is the ratio of the Emissions(kt) in Japan in 1968 to that in 1969?
Offer a terse response. 0.83. What is the ratio of the Emissions(kt) of Solomon Islands in 1968 to that in 1969?
Make the answer very short. 1. What is the ratio of the Emissions(kt) in St. Lucia in 1968 to that in 1969?
Offer a very short reply. 0.59. What is the ratio of the Emissions(kt) of Costa Rica in 1968 to that in 1970?
Your response must be concise. 0.84. What is the ratio of the Emissions(kt) of Japan in 1968 to that in 1970?
Give a very brief answer. 0.66. What is the ratio of the Emissions(kt) in Solomon Islands in 1968 to that in 1970?
Your answer should be compact. 0.91. What is the ratio of the Emissions(kt) of St. Lucia in 1968 to that in 1970?
Give a very brief answer. 0.56. What is the ratio of the Emissions(kt) of Costa Rica in 1968 to that in 1971?
Offer a terse response. 0.68. What is the ratio of the Emissions(kt) of Japan in 1968 to that in 1971?
Give a very brief answer. 0.6. What is the ratio of the Emissions(kt) in Solomon Islands in 1968 to that in 1971?
Provide a succinct answer. 0.77. What is the ratio of the Emissions(kt) of St. Lucia in 1968 to that in 1971?
Offer a very short reply. 0.53. What is the ratio of the Emissions(kt) in Costa Rica in 1968 to that in 1972?
Provide a short and direct response. 0.6. What is the ratio of the Emissions(kt) of Japan in 1968 to that in 1972?
Offer a very short reply. 0.55. What is the ratio of the Emissions(kt) of St. Lucia in 1968 to that in 1972?
Your response must be concise. 0.48. What is the ratio of the Emissions(kt) in Costa Rica in 1968 to that in 1973?
Give a very brief answer. 0.51. What is the ratio of the Emissions(kt) of Japan in 1968 to that in 1973?
Your response must be concise. 0.51. What is the ratio of the Emissions(kt) of Solomon Islands in 1968 to that in 1973?
Your response must be concise. 0.56. What is the ratio of the Emissions(kt) in St. Lucia in 1968 to that in 1973?
Provide a succinct answer. 0.45. What is the ratio of the Emissions(kt) in Costa Rica in 1968 to that in 1974?
Keep it short and to the point. 0.55. What is the ratio of the Emissions(kt) in Japan in 1968 to that in 1974?
Make the answer very short. 0.53. What is the ratio of the Emissions(kt) of Solomon Islands in 1968 to that in 1974?
Your response must be concise. 0.56. What is the ratio of the Emissions(kt) in St. Lucia in 1968 to that in 1974?
Your response must be concise. 0.5. What is the ratio of the Emissions(kt) in Costa Rica in 1969 to that in 1970?
Provide a short and direct response. 0.92. What is the ratio of the Emissions(kt) of Japan in 1969 to that in 1970?
Make the answer very short. 0.8. What is the ratio of the Emissions(kt) of St. Lucia in 1969 to that in 1970?
Ensure brevity in your answer.  0.94. What is the ratio of the Emissions(kt) in Japan in 1969 to that in 1971?
Give a very brief answer. 0.73. What is the ratio of the Emissions(kt) in Solomon Islands in 1969 to that in 1971?
Make the answer very short. 0.77. What is the ratio of the Emissions(kt) of St. Lucia in 1969 to that in 1971?
Your answer should be very brief. 0.89. What is the ratio of the Emissions(kt) in Costa Rica in 1969 to that in 1972?
Your answer should be compact. 0.65. What is the ratio of the Emissions(kt) in Japan in 1969 to that in 1972?
Give a very brief answer. 0.66. What is the ratio of the Emissions(kt) of Solomon Islands in 1969 to that in 1972?
Keep it short and to the point. 0.67. What is the ratio of the Emissions(kt) of St. Lucia in 1969 to that in 1972?
Your answer should be compact. 0.81. What is the ratio of the Emissions(kt) in Costa Rica in 1969 to that in 1973?
Give a very brief answer. 0.56. What is the ratio of the Emissions(kt) of Japan in 1969 to that in 1973?
Make the answer very short. 0.62. What is the ratio of the Emissions(kt) of Solomon Islands in 1969 to that in 1973?
Your answer should be compact. 0.56. What is the ratio of the Emissions(kt) in St. Lucia in 1969 to that in 1973?
Ensure brevity in your answer.  0.77. What is the ratio of the Emissions(kt) in Costa Rica in 1969 to that in 1974?
Your answer should be compact. 0.61. What is the ratio of the Emissions(kt) in Japan in 1969 to that in 1974?
Give a very brief answer. 0.63. What is the ratio of the Emissions(kt) of Solomon Islands in 1969 to that in 1974?
Your answer should be very brief. 0.56. What is the ratio of the Emissions(kt) of St. Lucia in 1969 to that in 1974?
Offer a very short reply. 0.85. What is the ratio of the Emissions(kt) of Costa Rica in 1970 to that in 1971?
Keep it short and to the point. 0.81. What is the ratio of the Emissions(kt) in Japan in 1970 to that in 1971?
Provide a short and direct response. 0.91. What is the ratio of the Emissions(kt) of Solomon Islands in 1970 to that in 1971?
Offer a terse response. 0.85. What is the ratio of the Emissions(kt) of Costa Rica in 1970 to that in 1972?
Keep it short and to the point. 0.71. What is the ratio of the Emissions(kt) of Japan in 1970 to that in 1972?
Make the answer very short. 0.82. What is the ratio of the Emissions(kt) in Solomon Islands in 1970 to that in 1972?
Offer a terse response. 0.73. What is the ratio of the Emissions(kt) in St. Lucia in 1970 to that in 1972?
Offer a very short reply. 0.86. What is the ratio of the Emissions(kt) of Costa Rica in 1970 to that in 1973?
Ensure brevity in your answer.  0.61. What is the ratio of the Emissions(kt) of Japan in 1970 to that in 1973?
Your response must be concise. 0.77. What is the ratio of the Emissions(kt) of Solomon Islands in 1970 to that in 1973?
Keep it short and to the point. 0.61. What is the ratio of the Emissions(kt) in St. Lucia in 1970 to that in 1973?
Provide a succinct answer. 0.82. What is the ratio of the Emissions(kt) in Costa Rica in 1970 to that in 1974?
Make the answer very short. 0.66. What is the ratio of the Emissions(kt) in Japan in 1970 to that in 1974?
Offer a terse response. 0.79. What is the ratio of the Emissions(kt) of Solomon Islands in 1970 to that in 1974?
Provide a succinct answer. 0.61. What is the ratio of the Emissions(kt) of Costa Rica in 1971 to that in 1972?
Your response must be concise. 0.87. What is the ratio of the Emissions(kt) of Japan in 1971 to that in 1972?
Keep it short and to the point. 0.9. What is the ratio of the Emissions(kt) in Solomon Islands in 1971 to that in 1972?
Give a very brief answer. 0.87. What is the ratio of the Emissions(kt) in St. Lucia in 1971 to that in 1972?
Offer a very short reply. 0.9. What is the ratio of the Emissions(kt) in Costa Rica in 1971 to that in 1973?
Offer a terse response. 0.74. What is the ratio of the Emissions(kt) in Japan in 1971 to that in 1973?
Give a very brief answer. 0.85. What is the ratio of the Emissions(kt) in Solomon Islands in 1971 to that in 1973?
Give a very brief answer. 0.72. What is the ratio of the Emissions(kt) in St. Lucia in 1971 to that in 1973?
Offer a very short reply. 0.86. What is the ratio of the Emissions(kt) of Costa Rica in 1971 to that in 1974?
Your answer should be compact. 0.81. What is the ratio of the Emissions(kt) of Japan in 1971 to that in 1974?
Your response must be concise. 0.87. What is the ratio of the Emissions(kt) of Solomon Islands in 1971 to that in 1974?
Your answer should be very brief. 0.72. What is the ratio of the Emissions(kt) in Costa Rica in 1972 to that in 1973?
Your response must be concise. 0.85. What is the ratio of the Emissions(kt) of Japan in 1972 to that in 1973?
Ensure brevity in your answer.  0.94. What is the ratio of the Emissions(kt) in St. Lucia in 1972 to that in 1973?
Give a very brief answer. 0.95. What is the ratio of the Emissions(kt) of Costa Rica in 1972 to that in 1974?
Offer a very short reply. 0.93. What is the ratio of the Emissions(kt) in Japan in 1972 to that in 1974?
Give a very brief answer. 0.96. What is the ratio of the Emissions(kt) in Solomon Islands in 1972 to that in 1974?
Provide a succinct answer. 0.83. What is the ratio of the Emissions(kt) in Costa Rica in 1973 to that in 1974?
Offer a terse response. 1.09. What is the ratio of the Emissions(kt) of Japan in 1973 to that in 1974?
Keep it short and to the point. 1.02. What is the ratio of the Emissions(kt) in Solomon Islands in 1973 to that in 1974?
Keep it short and to the point. 1. What is the ratio of the Emissions(kt) of St. Lucia in 1973 to that in 1974?
Provide a short and direct response. 1.1. What is the difference between the highest and the second highest Emissions(kt) of Costa Rica?
Make the answer very short. 150.35. What is the difference between the highest and the second highest Emissions(kt) in Japan?
Your answer should be compact. 1.58e+04. What is the difference between the highest and the second highest Emissions(kt) in Solomon Islands?
Your answer should be very brief. 0. What is the difference between the highest and the second highest Emissions(kt) of St. Lucia?
Offer a terse response. 3.67. What is the difference between the highest and the lowest Emissions(kt) in Costa Rica?
Give a very brief answer. 938.75. What is the difference between the highest and the lowest Emissions(kt) in Japan?
Keep it short and to the point. 3.17e+05. What is the difference between the highest and the lowest Emissions(kt) in Solomon Islands?
Your answer should be compact. 29.34. What is the difference between the highest and the lowest Emissions(kt) in St. Lucia?
Keep it short and to the point. 44. 